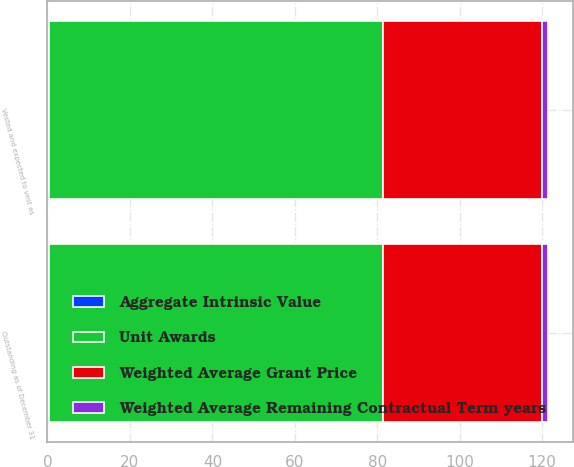Convert chart to OTSL. <chart><loc_0><loc_0><loc_500><loc_500><stacked_bar_chart><ecel><fcel>Outstanding as of December 31<fcel>Vested and expected to vest as<nl><fcel>Weighted Average Remaining Contractual Term years<fcel>1.6<fcel>1.6<nl><fcel>Weighted Average Grant Price<fcel>38.46<fcel>38.46<nl><fcel>Aggregate Intrinsic Value<fcel>0.4<fcel>0.4<nl><fcel>Unit Awards<fcel>81<fcel>81<nl></chart> 